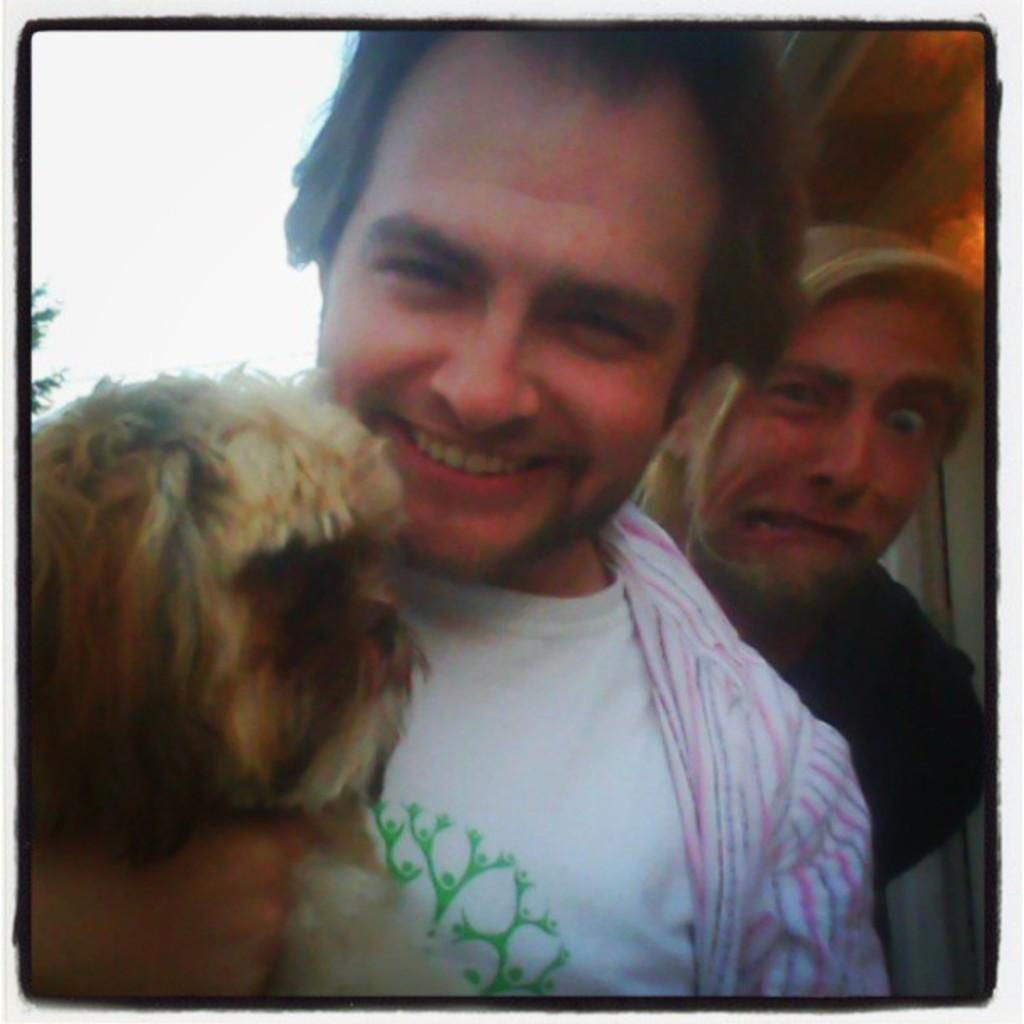How many people are in the image? There are two people in the image. What is one of the people doing with an animal? One person is holding a dog. What is the emotional state of the person holding the dog? The person holding the dog is smiling. What else can be seen in the image besides the people and the dog? There are other objects in the image. What is visible in the background of the image? The sky is visible in the image. How many stems can be seen growing from the cows in the image? There are no cows present in the image, so there are no stems growing from them. What type of station is visible in the image? There is no station visible in the image. 